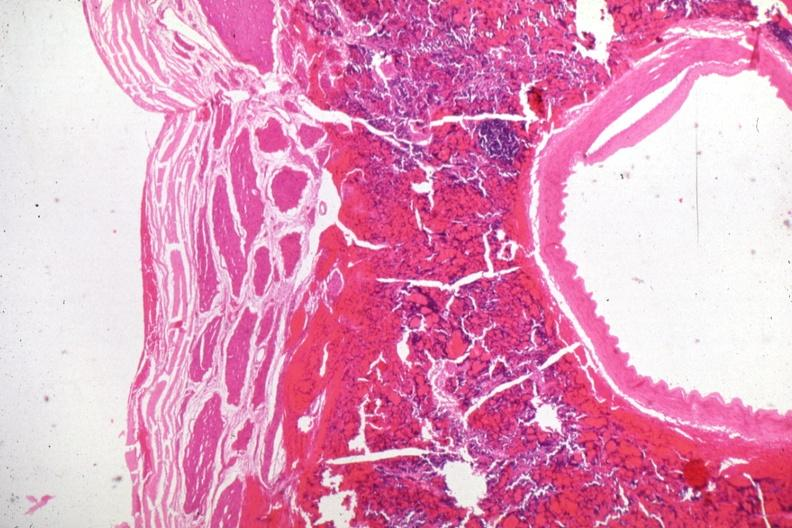s cachexia present?
Answer the question using a single word or phrase. No 